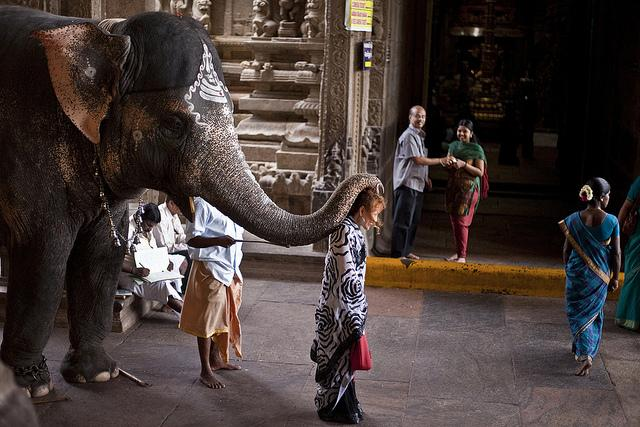What is the type of garment that the woman in blue is wearing?

Choices:
A) raincoat
B) chut thai
C) kimono
D) sari sari 